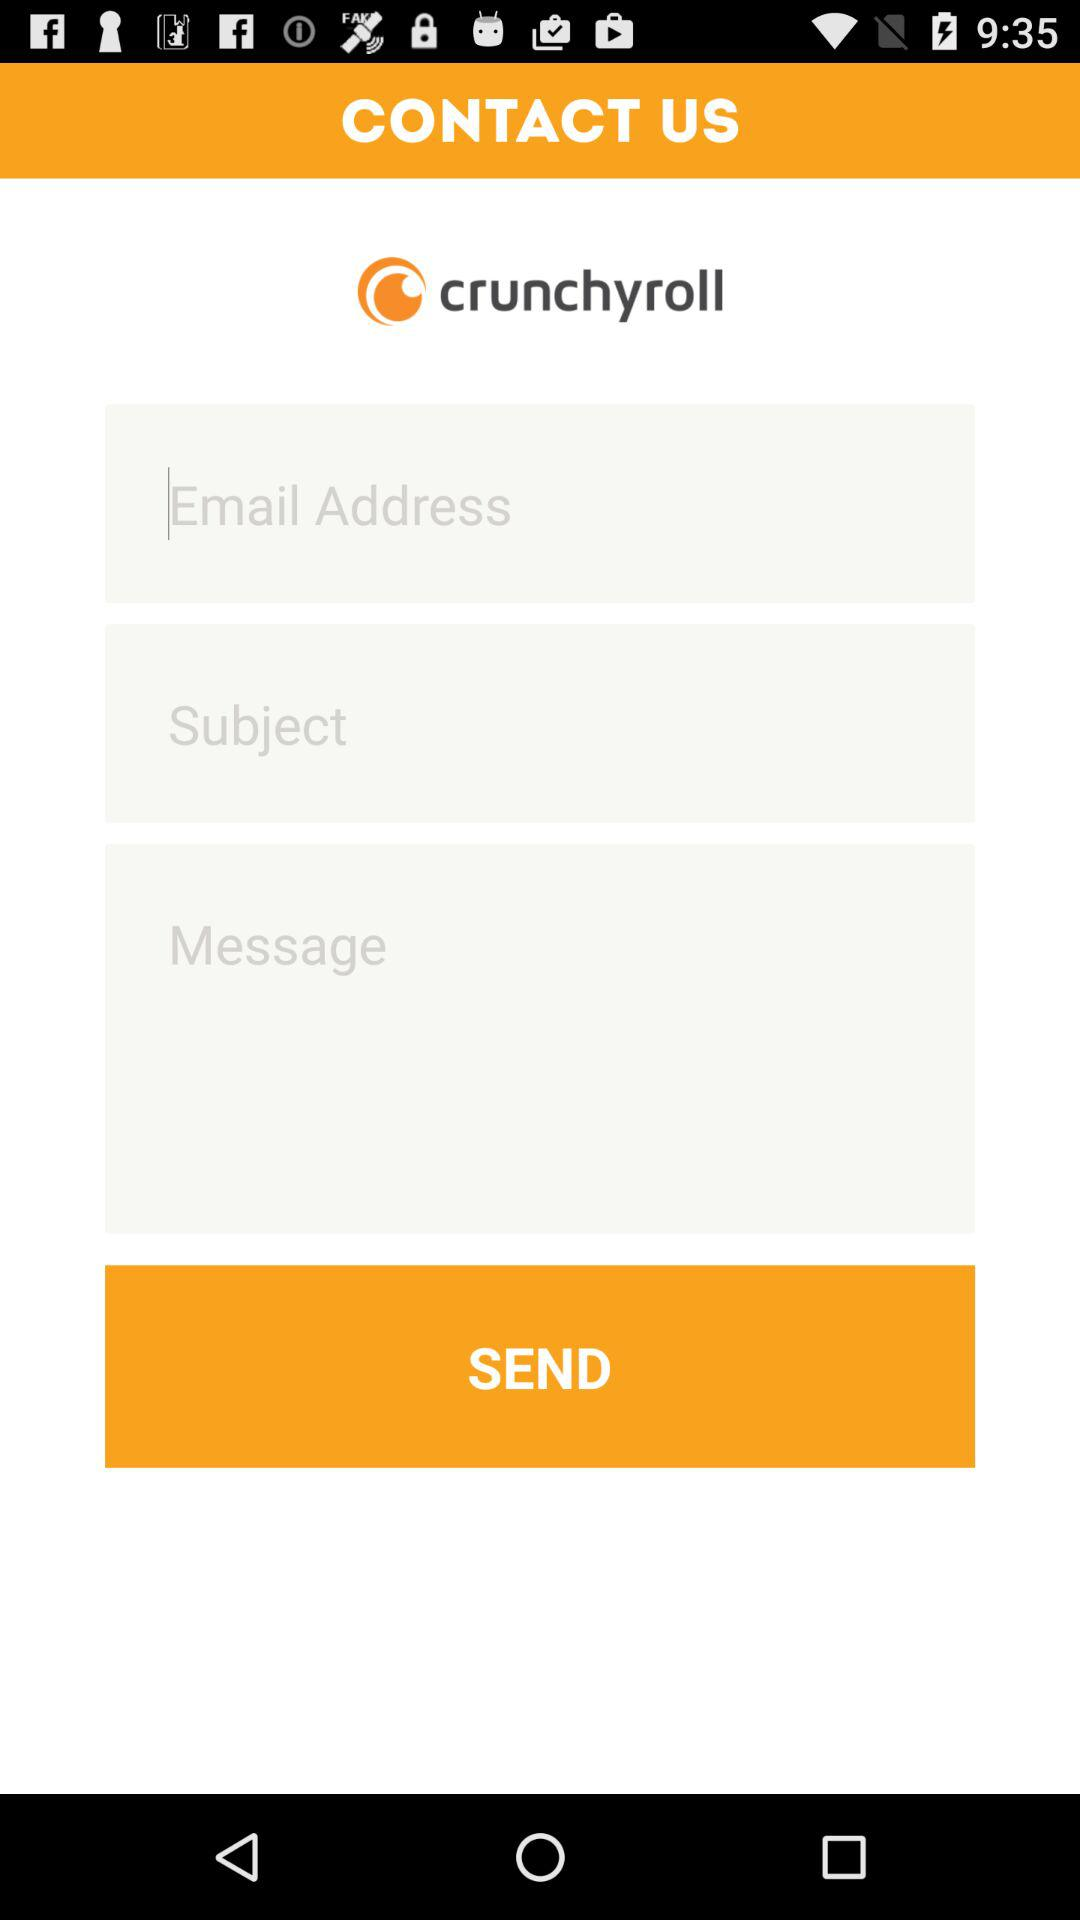What is the application name? The application name is "crunchyroll". 